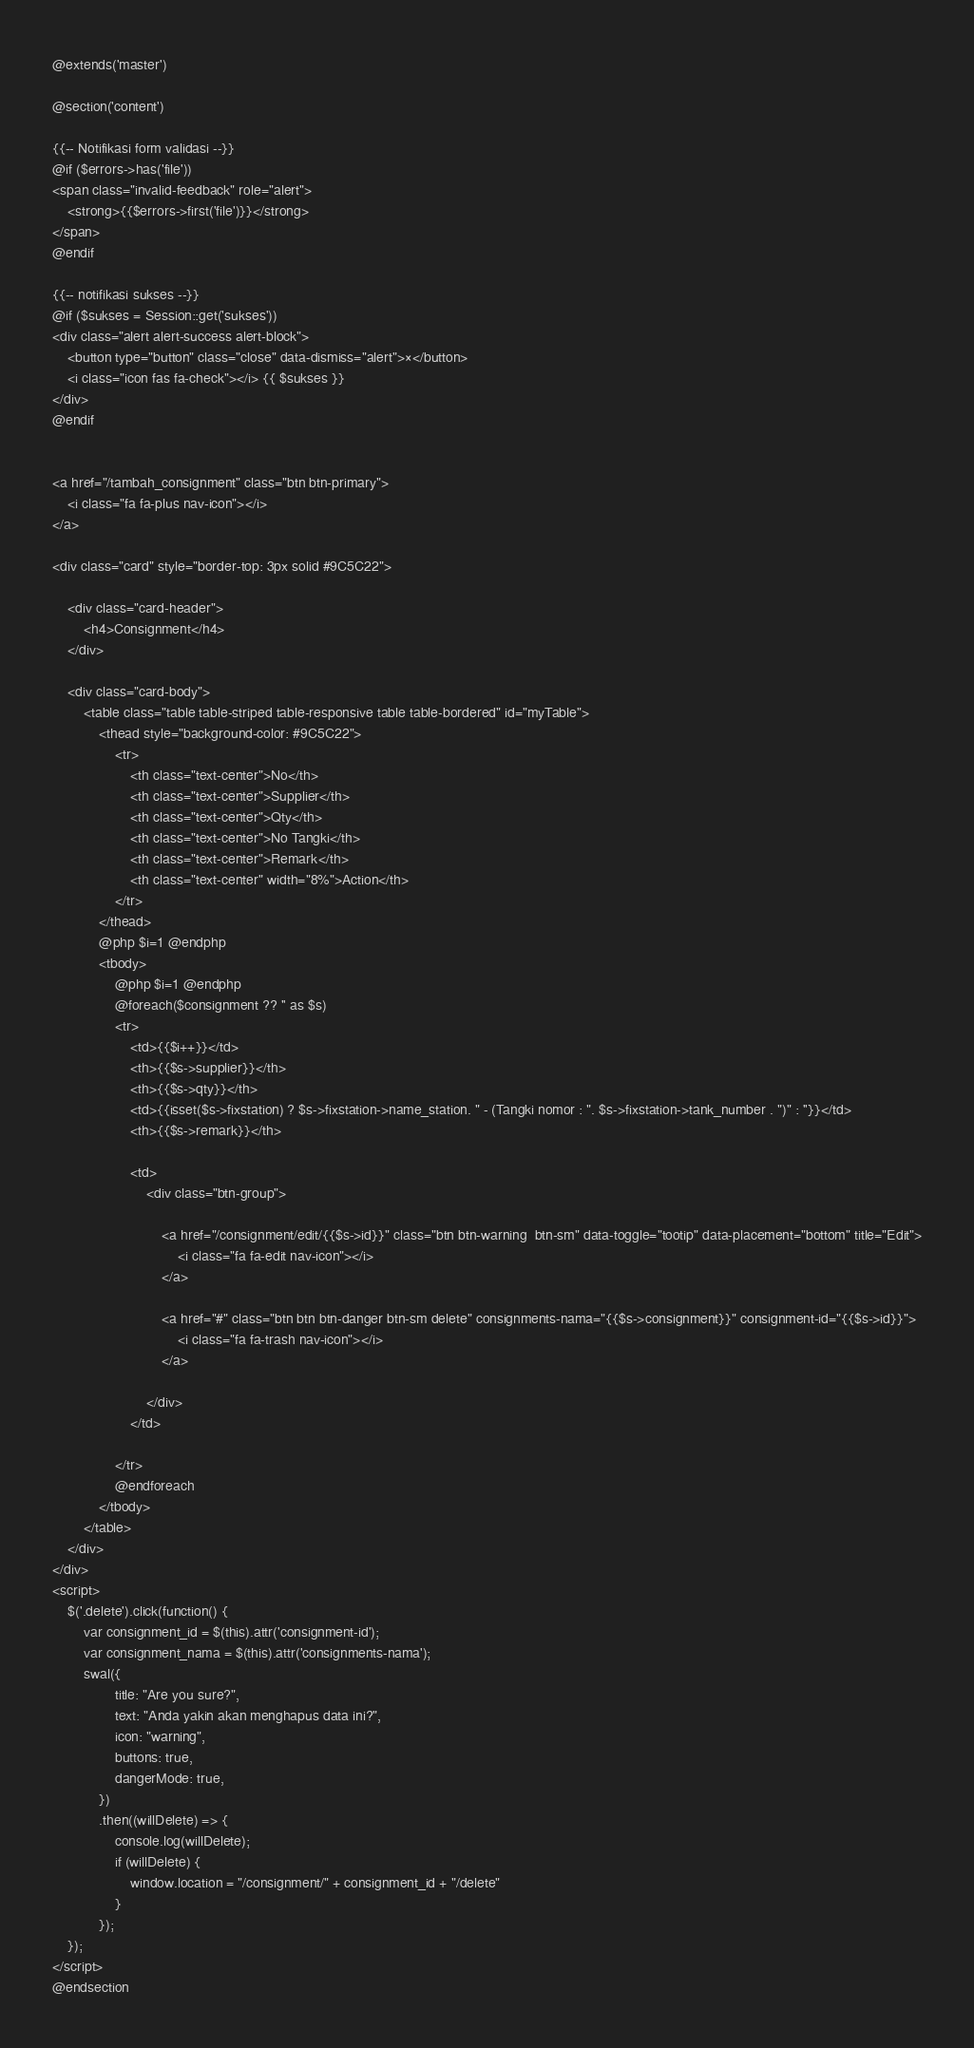Convert code to text. <code><loc_0><loc_0><loc_500><loc_500><_PHP_>@extends('master')

@section('content')

{{-- Notifikasi form validasi --}}
@if ($errors->has('file'))
<span class="invalid-feedback" role="alert">
    <strong>{{$errors->first('file')}}</strong>
</span>
@endif

{{-- notifikasi sukses --}}
@if ($sukses = Session::get('sukses'))
<div class="alert alert-success alert-block">
    <button type="button" class="close" data-dismiss="alert">×</button>
    <i class="icon fas fa-check"></i> {{ $sukses }}
</div>
@endif


<a href="/tambah_consignment" class="btn btn-primary">
    <i class="fa fa-plus nav-icon"></i>
</a>

<div class="card" style="border-top: 3px solid #9C5C22">

    <div class="card-header">
        <h4>Consignment</h4>
    </div>

    <div class="card-body">
        <table class="table table-striped table-responsive table table-bordered" id="myTable">
            <thead style="background-color: #9C5C22">
                <tr>
                    <th class="text-center">No</th>
                    <th class="text-center">Supplier</th>
                    <th class="text-center">Qty</th>
                    <th class="text-center">No Tangki</th>
                    <th class="text-center">Remark</th>
                    <th class="text-center" width="8%">Action</th>
                </tr>
            </thead>
            @php $i=1 @endphp
            <tbody>
                @php $i=1 @endphp
                @foreach($consignment ?? '' as $s)
                <tr>
                    <td>{{$i++}}</td>
                    <th>{{$s->supplier}}</th>
                    <th>{{$s->qty}}</th>
                    <td>{{isset($s->fixstation) ? $s->fixstation->name_station. " - (Tangki nomor : ". $s->fixstation->tank_number . ")" : ''}}</td>
                    <th>{{$s->remark}}</th>

                    <td>
                        <div class="btn-group">

                            <a href="/consignment/edit/{{$s->id}}" class="btn btn-warning  btn-sm" data-toggle="tootip" data-placement="bottom" title="Edit">
                                <i class="fa fa-edit nav-icon"></i>
                            </a>

                            <a href="#" class="btn btn btn-danger btn-sm delete" consignments-nama="{{$s->consignment}}" consignment-id="{{$s->id}}">
                                <i class="fa fa-trash nav-icon"></i>
                            </a>

                        </div>
                    </td>

                </tr>
                @endforeach
            </tbody>
        </table>
    </div>
</div>
<script>
    $('.delete').click(function() {
        var consignment_id = $(this).attr('consignment-id');
        var consignment_nama = $(this).attr('consignments-nama');
        swal({
                title: "Are you sure?",
                text: "Anda yakin akan menghapus data ini?",
                icon: "warning",
                buttons: true,
                dangerMode: true,
            })
            .then((willDelete) => {
                console.log(willDelete);
                if (willDelete) {
                    window.location = "/consignment/" + consignment_id + "/delete"
                }
            });
    });
</script>
@endsection</code> 